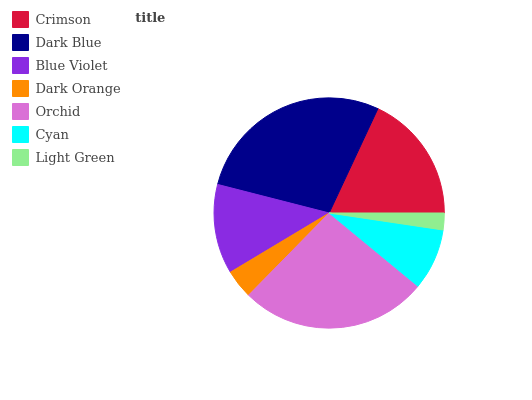Is Light Green the minimum?
Answer yes or no. Yes. Is Dark Blue the maximum?
Answer yes or no. Yes. Is Blue Violet the minimum?
Answer yes or no. No. Is Blue Violet the maximum?
Answer yes or no. No. Is Dark Blue greater than Blue Violet?
Answer yes or no. Yes. Is Blue Violet less than Dark Blue?
Answer yes or no. Yes. Is Blue Violet greater than Dark Blue?
Answer yes or no. No. Is Dark Blue less than Blue Violet?
Answer yes or no. No. Is Blue Violet the high median?
Answer yes or no. Yes. Is Blue Violet the low median?
Answer yes or no. Yes. Is Crimson the high median?
Answer yes or no. No. Is Dark Blue the low median?
Answer yes or no. No. 